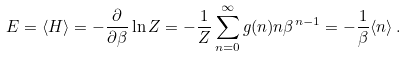<formula> <loc_0><loc_0><loc_500><loc_500>E = \langle H \rangle = - \frac { \partial } { \partial \beta } \ln Z = - \frac { 1 } { Z } \sum _ { n = 0 } ^ { \infty } g ( n ) n \beta ^ { n - 1 } = - \frac { 1 } { \beta } \langle n \rangle \, .</formula> 